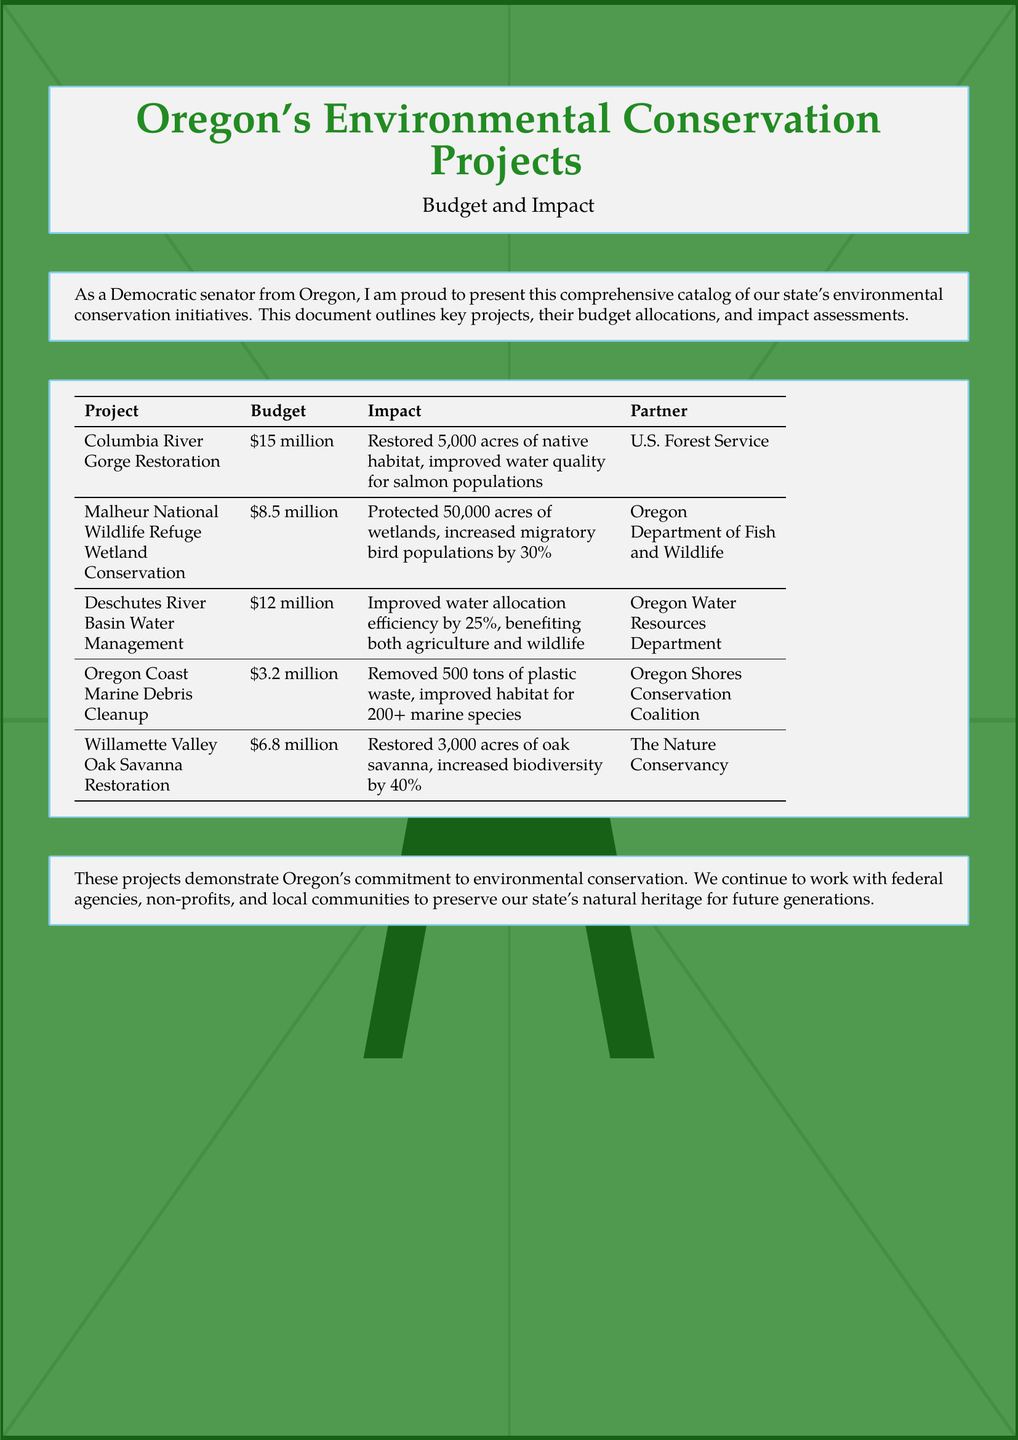What is the budget for the Columbia River Gorge Restoration project? The budget is specified in the document for each project; for the Columbia River Gorge Restoration, it is $15 million.
Answer: $15 million How many acres were restored in the Columbia River Gorge Restoration project? The document provides details about the impact of each project, indicating that 5,000 acres were restored.
Answer: 5,000 acres What was the increase in migratory bird populations due to the Malheur National Wildlife Refuge Wetland Conservation project? The impact mentioned in the document states an increase of 30% in migratory bird populations resulting from this project.
Answer: 30% What type of habitat was restored in the Willamette Valley project? The document identifies the specific habitat restored as oak savanna for the Willamette Valley project.
Answer: oak savanna Which organization partnered in the Oregon Coast Marine Debris Cleanup? The partners for each project are listed in the document; the Oregon Shores Conservation Coalition is the partner for the Marine Debris Cleanup project.
Answer: Oregon Shores Conservation Coalition What is the total budget allocated for the Deschutes River Basin Water Management? The budget for this project is specifically mentioned in the document as $12 million.
Answer: $12 million Which project aimed to improve water quality for salmon populations? The document states that the Columbia River Gorge Restoration project has the goal of improving water quality for salmon populations.
Answer: Columbia River Gorge Restoration What is the total number of tons of plastic waste removed in the Marine Debris Cleanup? According to the impact assessment in the document, the project resulted in the removal of 500 tons of plastic waste.
Answer: 500 tons 